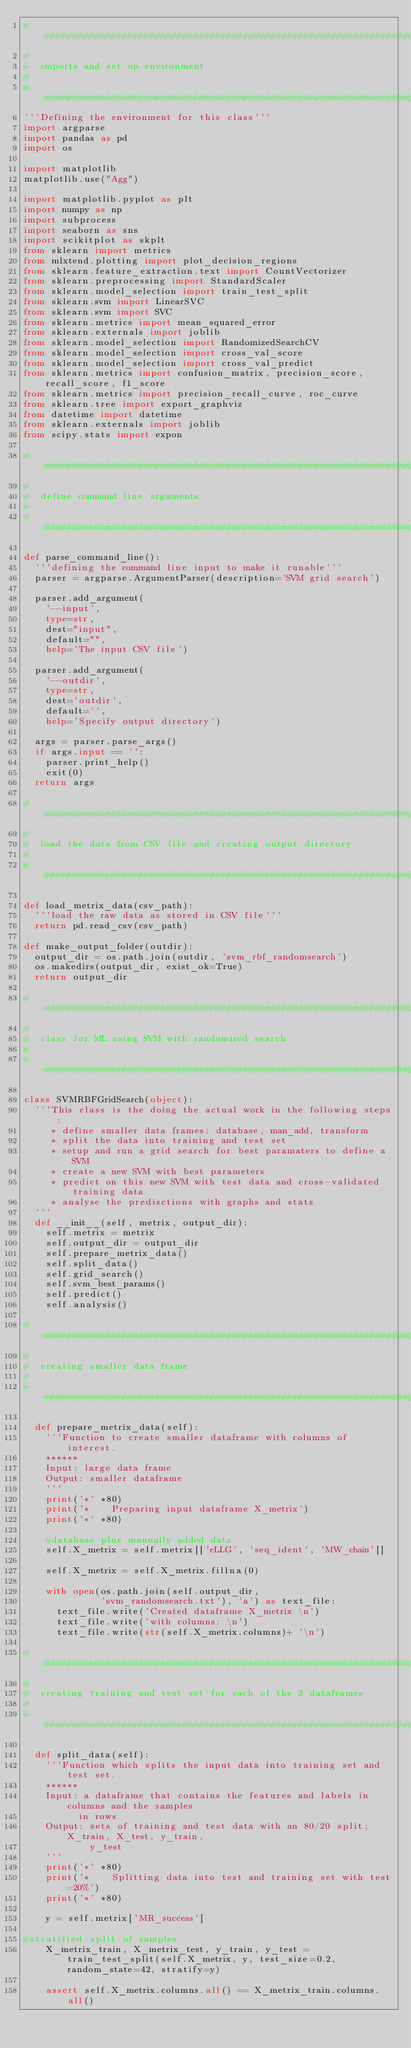Convert code to text. <code><loc_0><loc_0><loc_500><loc_500><_Python_>###############################################################################
#
#  imports and set up environment
#
###############################################################################
'''Defining the environment for this class'''
import argparse
import pandas as pd
import os

import matplotlib
matplotlib.use("Agg")

import matplotlib.pyplot as plt
import numpy as np
import subprocess
import seaborn as sns
import scikitplot as skplt
from sklearn import metrics
from mlxtend.plotting import plot_decision_regions
from sklearn.feature_extraction.text import CountVectorizer
from sklearn.preprocessing import StandardScaler
from sklearn.model_selection import train_test_split
from sklearn.svm import LinearSVC
from sklearn.svm import SVC
from sklearn.metrics import mean_squared_error
from sklearn.externals import joblib
from sklearn.model_selection import RandomizedSearchCV
from sklearn.model_selection import cross_val_score
from sklearn.model_selection import cross_val_predict
from sklearn.metrics import confusion_matrix, precision_score, recall_score, f1_score
from sklearn.metrics import precision_recall_curve, roc_curve
from sklearn.tree import export_graphviz
from datetime import datetime
from sklearn.externals import joblib
from scipy.stats import expon

###############################################################################
#
#  define command line arguments
#
###############################################################################

def parse_command_line():
  '''defining the command line input to make it runable'''
  parser = argparse.ArgumentParser(description='SVM grid search')
  
  parser.add_argument(
    '--input', 
    type=str, 
    dest="input",
    default="",
    help='The input CSV file')
    
  parser.add_argument(
    '--outdir',
    type=str,
    dest='outdir',
    default='',
    help='Specify output directory')

  args = parser.parse_args()
  if args.input == '':
    parser.print_help()
    exit(0)
  return args

###############################################################################
#
#  load the data from CSV file and creating output directory
#
###############################################################################

def load_metrix_data(csv_path):
  '''load the raw data as stored in CSV file'''
  return pd.read_csv(csv_path)

def make_output_folder(outdir):
  output_dir = os.path.join(outdir, 'svm_rbf_randomsearch')
  os.makedirs(output_dir, exist_ok=True)
  return output_dir

###############################################################################
#
#  class for ML using SVM with randomised search
#
###############################################################################

class SVMRBFGridSearch(object):
  '''This class is the doing the actual work in the following steps:
     * define smaller data frames: database, man_add, transform
     * split the data into training and test set
     * setup and run a grid search for best paramaters to define a SVM
     * create a new SVM with best parameters
     * predict on this new SVM with test data and cross-validated training data
     * analyse the predisctions with graphs and stats
  '''
  def __init__(self, metrix, output_dir):
    self.metrix = metrix
    self.output_dir = output_dir
    self.prepare_metrix_data()
    self.split_data()
    self.grid_search()
    self.svm_best_params()
    self.predict()
    self.analysis()

###############################################################################
#
#  creating smaller data frame
#
###############################################################################

  def prepare_metrix_data(self):
    '''Function to create smaller dataframe with columns of interest.
    ******
    Input: large data frame
    Output: smaller dataframe
    '''
    print('*' *80)
    print('*    Preparing input dataframe X_metrix')
    print('*' *80)

    #database plus manually added data
    self.X_metrix = self.metrix[['eLLG', 'seq_ident', 'MW_chain']]

    self.X_metrix = self.X_metrix.fillna(0)

    with open(os.path.join(self.output_dir,
              'svm_randomsearch.txt'), 'a') as text_file:
      text_file.write('Created dataframe X_metrix \n')
      text_file.write('with columns: \n')
      text_file.write(str(self.X_metrix.columns)+ '\n')

###############################################################################
#
#  creating training and test set for each of the 3 dataframes
#
###############################################################################

  def split_data(self):
    '''Function which splits the input data into training set and test set.
    ******
    Input: a dataframe that contains the features and labels in columns and the samples
          in rows
    Output: sets of training and test data with an 80/20 split; X_train, X_test, y_train,
            y_test
    '''
    print('*' *80)
    print('*    Splitting data into test and training set with test=20%')
    print('*' *80)

    y = self.metrix['MR_success']

#stratified split of samples
    X_metrix_train, X_metrix_test, y_train, y_test = train_test_split(self.X_metrix, y, test_size=0.2, random_state=42, stratify=y)
    
    assert self.X_metrix.columns.all() == X_metrix_train.columns.all()
</code> 